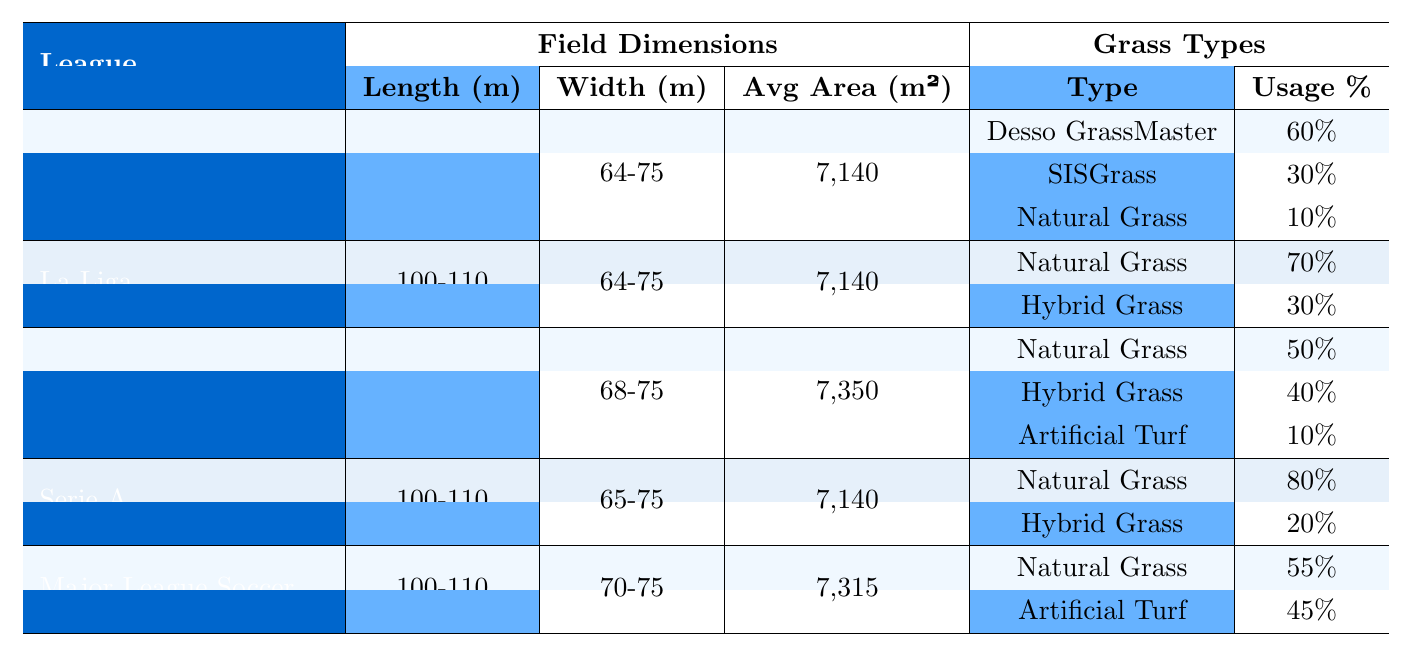What are the field dimensions for Major League Soccer? The table shows that the field dimensions for Major League Soccer are a length of 100-110 meters and a width of 70-75 meters.
Answer: 100-110 meters long and 70-75 meters wide Which league uses Desso GrassMaster, and what is its usage percentage? According to the table, Desso GrassMaster is used in the English Premier League with a usage percentage of 60%.
Answer: English Premier League; 60% What is the average area (in square meters) of the Bundesliga fields? The table states that the average area of the Bundesliga fields is 7,350 square meters.
Answer: 7,350 square meters Is the width range of Serie A fields greater than that of the Bundesliga? The width range for Serie A is 65-75 meters, while for the Bundesliga, it is 68-75 meters. Since 68-75 includes all values of 65-75, the width range of Serie A is not greater.
Answer: No What percentage of grass used in La Liga is hybrid grass? The table indicates that hybrid grass accounts for 30% of the grass types used in La Liga.
Answer: 30% In which league is the average area of the field the largest? The average areas from the table show Bundesliga at 7,350 sq m, Major League Soccer at 7,315 sq m, and others at 7,140 sq m. Therefore, the Bundesliga has the largest average area.
Answer: Bundesliga If we sum the usage percentages of grass types used in Serie A, what do we get? The usage percentages in Serie A are 80% for Natural Grass and 20% for Hybrid Grass. Adding them gives 80 + 20 = 100%.
Answer: 100% Which league has the highest usage percentage of Natural Grass? Looking at the table, Serie A has the highest usage percentage of Natural Grass at 80%.
Answer: Serie A What is the difference in average area between the Bundesliga and Major League Soccer? The Bundesliga has an average area of 7,350 sq m and Major League Soccer has 7,315 sq m. Subtracting these gives 7,350 - 7,315 = 35 sq m.
Answer: 35 sq m Are there any leagues that use Artificial Turf? The table shows that Artificial Turf is used in the Bundesliga (10%) and Major League Soccer (45%), indicating that both leagues use Artificial Turf.
Answer: Yes 